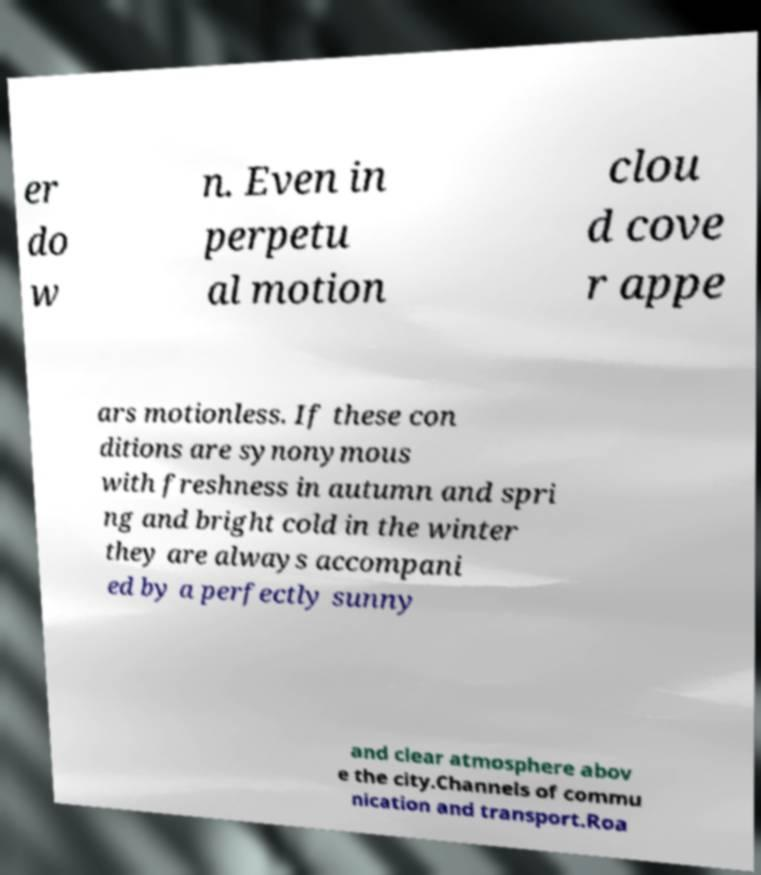Can you read and provide the text displayed in the image?This photo seems to have some interesting text. Can you extract and type it out for me? er do w n. Even in perpetu al motion clou d cove r appe ars motionless. If these con ditions are synonymous with freshness in autumn and spri ng and bright cold in the winter they are always accompani ed by a perfectly sunny and clear atmosphere abov e the city.Channels of commu nication and transport.Roa 